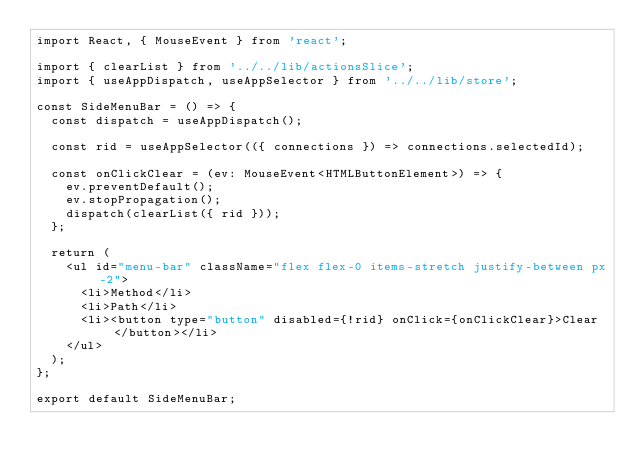<code> <loc_0><loc_0><loc_500><loc_500><_TypeScript_>import React, { MouseEvent } from 'react';

import { clearList } from '../../lib/actionsSlice';
import { useAppDispatch, useAppSelector } from '../../lib/store';

const SideMenuBar = () => {
  const dispatch = useAppDispatch();

  const rid = useAppSelector(({ connections }) => connections.selectedId);

  const onClickClear = (ev: MouseEvent<HTMLButtonElement>) => {
    ev.preventDefault();
    ev.stopPropagation();
    dispatch(clearList({ rid }));
  };

  return (
    <ul id="menu-bar" className="flex flex-0 items-stretch justify-between px-2">
      <li>Method</li>
      <li>Path</li>
      <li><button type="button" disabled={!rid} onClick={onClickClear}>Clear</button></li>
    </ul>
  );
};

export default SideMenuBar;
</code> 